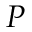<formula> <loc_0><loc_0><loc_500><loc_500>P</formula> 